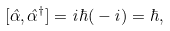<formula> <loc_0><loc_0><loc_500><loc_500>[ \hat { \alpha } , \hat { \alpha } ^ { \dagger } ] = i \hbar { ( } - i ) = \hbar { , }</formula> 